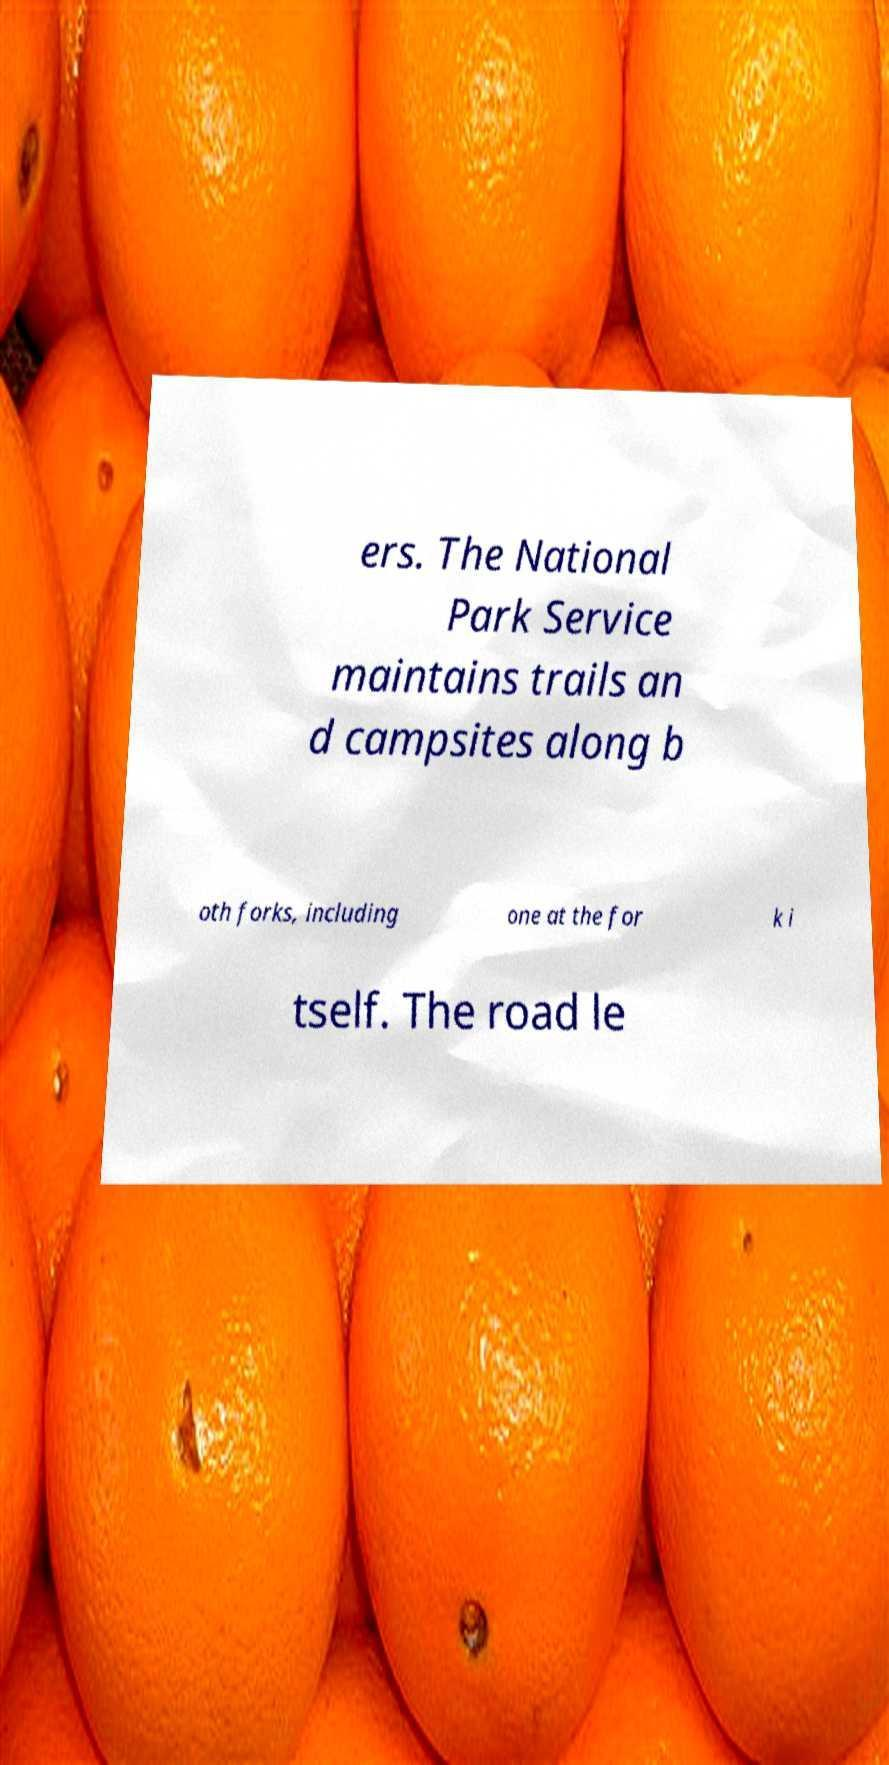Could you extract and type out the text from this image? ers. The National Park Service maintains trails an d campsites along b oth forks, including one at the for k i tself. The road le 